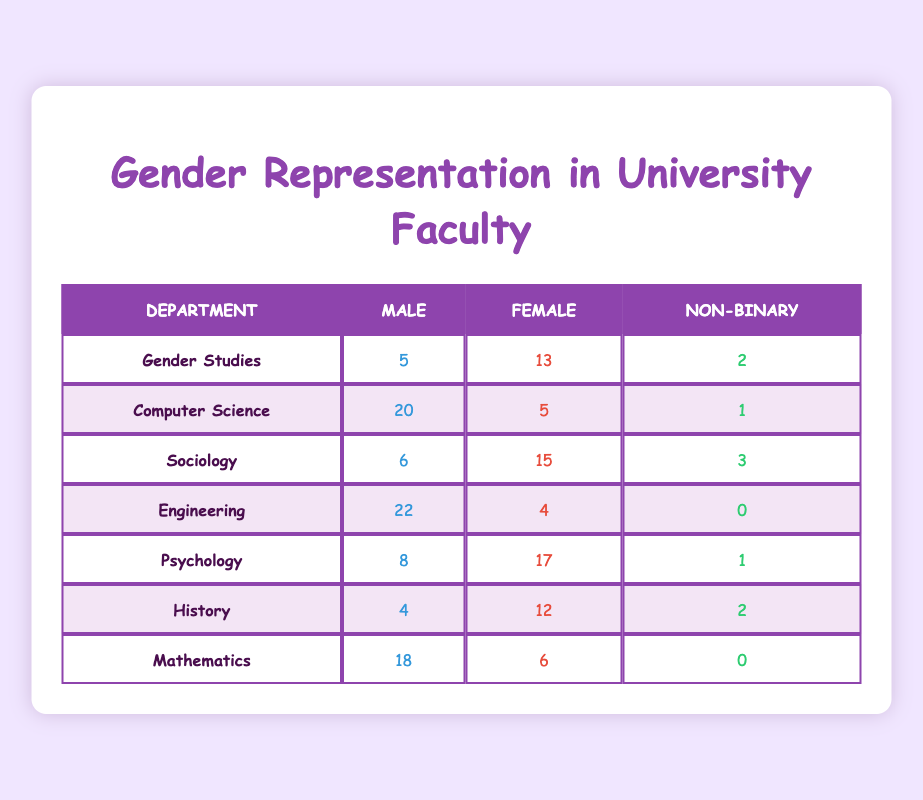What is the total number of male faculty members across all departments? To find the total number of male faculty across all departments, I sum the male faculty numbers from each department: 5 (Gender Studies) + 20 (Computer Science) + 6 (Sociology) + 22 (Engineering) + 8 (Psychology) + 4 (History) + 18 (Mathematics) = 83.
Answer: 83 What percentage of faculty in Psychology are female? In the Psychology department, there are 17 female faculty members out of a total of 26 faculty members (8 male + 17 female + 1 non-binary). To find the percentage, I calculate (17/26) * 100 = 65.38%.
Answer: 65.38% Is there any department where non-binary faculty members do not exist? I can check each department for the presence of non-binary faculty members. Both Engineering and Mathematics have 0 non-binary faculty, confirming that indeed there are departments without any non-binary representation.
Answer: Yes Which department has the highest number of female faculty? I compare the female faculty counts across departments: Gender Studies (13), Computer Science (5), Sociology (15), Engineering (4), Psychology (17), History (12), Mathematics (6). The department with the highest count is Psychology with 17 female faculty members.
Answer: Psychology How many more female faculty members are there in Sociology than in Engineering? I find the number of female faculty in Sociology (15) and Engineering (4) and then calculate the difference. The difference is 15 - 4 = 11, showing that Sociology has 11 more female faculty than Engineering.
Answer: 11 What is the male to female ratio in the Computer Science department? The number of male faculty in Computer Science is 20 and female faculty is 5. The ratio is calculated as 20:5, which simplifies to 4:1.
Answer: 4:1 Is the total gender representation in Gender Studies more balanced than in Engineering? In Gender Studies, the total faculty is 5 male, 13 female, and 2 non-binary, giving a diverse representation. In Engineering, there are 22 male and 4 female, with no non-binary. Gender Studies has a more balanced representation compared to Engineering's male dominance.
Answer: Yes What is the average number of non-binary faculty members across all departments? I sum the non-binary faculty members: 2 (Gender Studies) + 1 (Computer Science) + 3 (Sociology) + 0 (Engineering) + 1 (Psychology) + 2 (History) + 0 (Mathematics) = 9. There are 7 departments, so the average is 9/7 = 1.29.
Answer: 1.29 